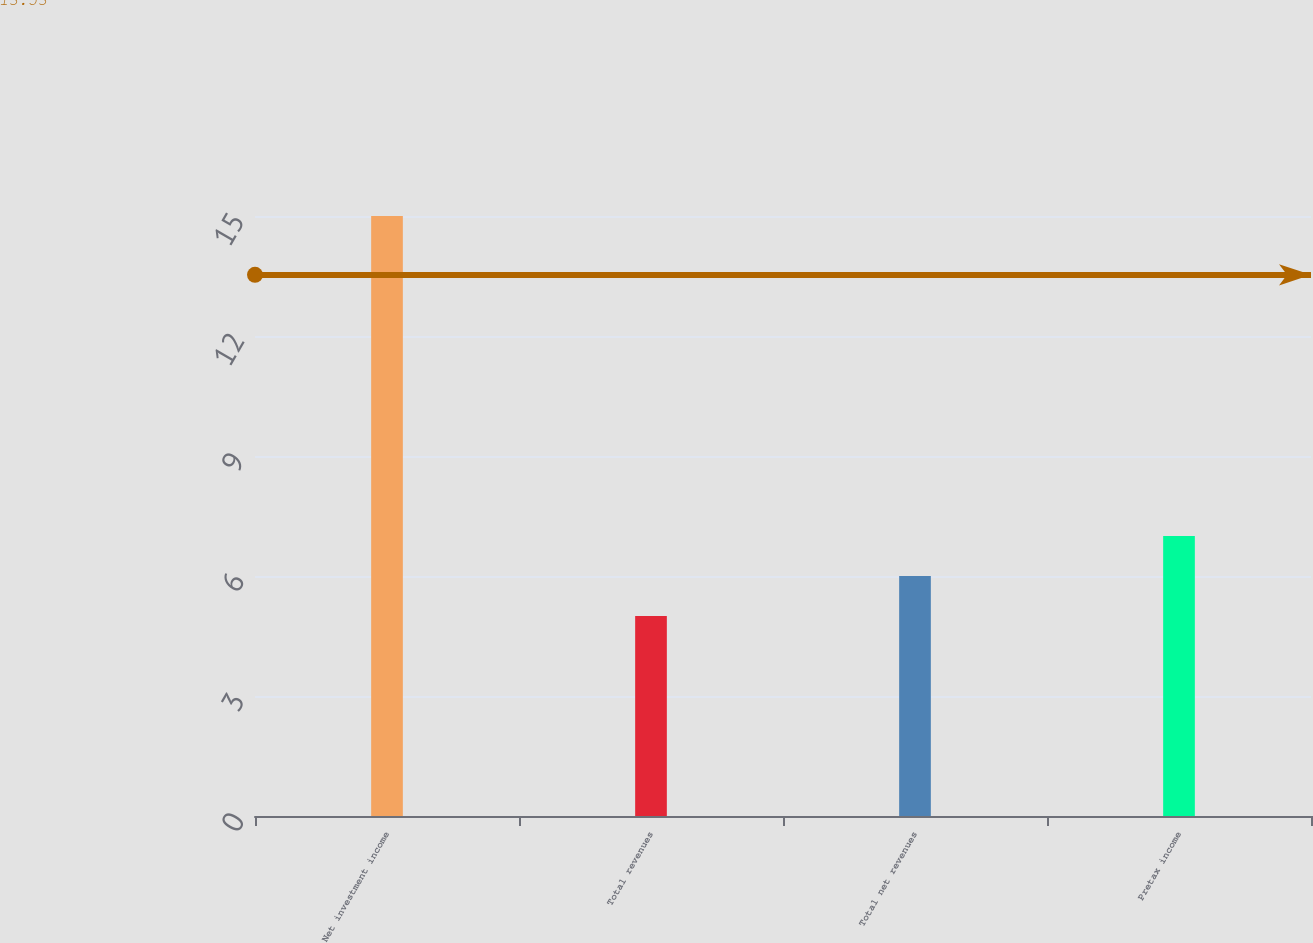Convert chart. <chart><loc_0><loc_0><loc_500><loc_500><bar_chart><fcel>Net investment income<fcel>Total revenues<fcel>Total net revenues<fcel>Pretax income<nl><fcel>15<fcel>5<fcel>6<fcel>7<nl></chart> 